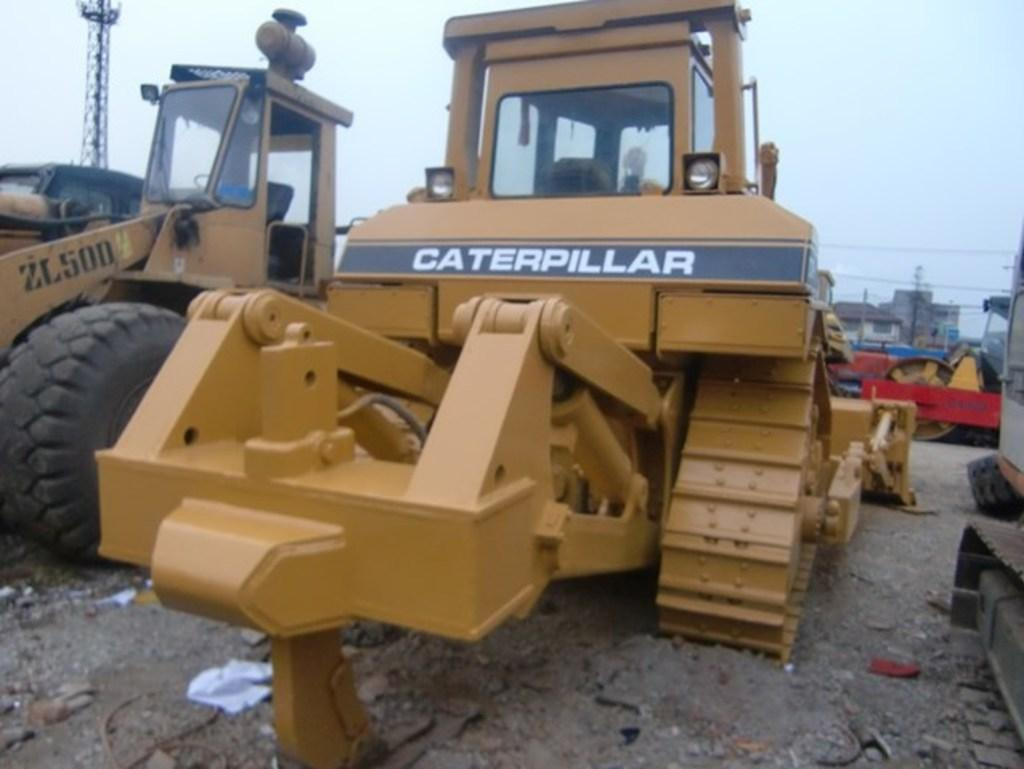What is the main subject in the center of the image? There are proclaimers in the center of the image. What is located at the bottom of the image? There is ground at the bottom of the image. What can be seen in the background of the image? There is sky and a tower visible in the background of the image. What type of fruit is being rolled on the ground in the image? There is no fruit or rolling action present in the image. 